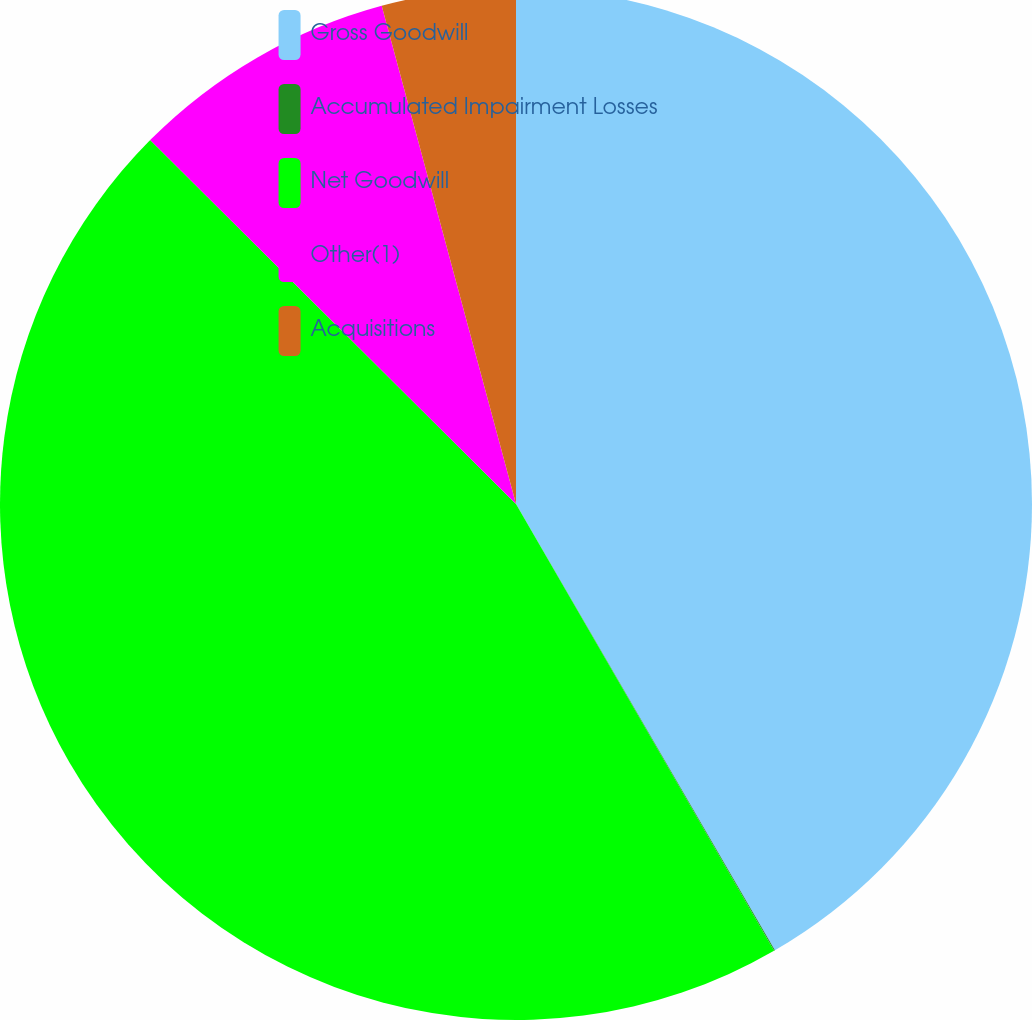Convert chart to OTSL. <chart><loc_0><loc_0><loc_500><loc_500><pie_chart><fcel>Gross Goodwill<fcel>Accumulated Impairment Losses<fcel>Net Goodwill<fcel>Other(1)<fcel>Acquisitions<nl><fcel>41.63%<fcel>0.03%<fcel>45.79%<fcel>8.35%<fcel>4.19%<nl></chart> 